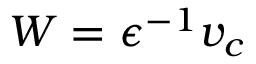<formula> <loc_0><loc_0><loc_500><loc_500>W = \epsilon ^ { - 1 } v _ { c }</formula> 